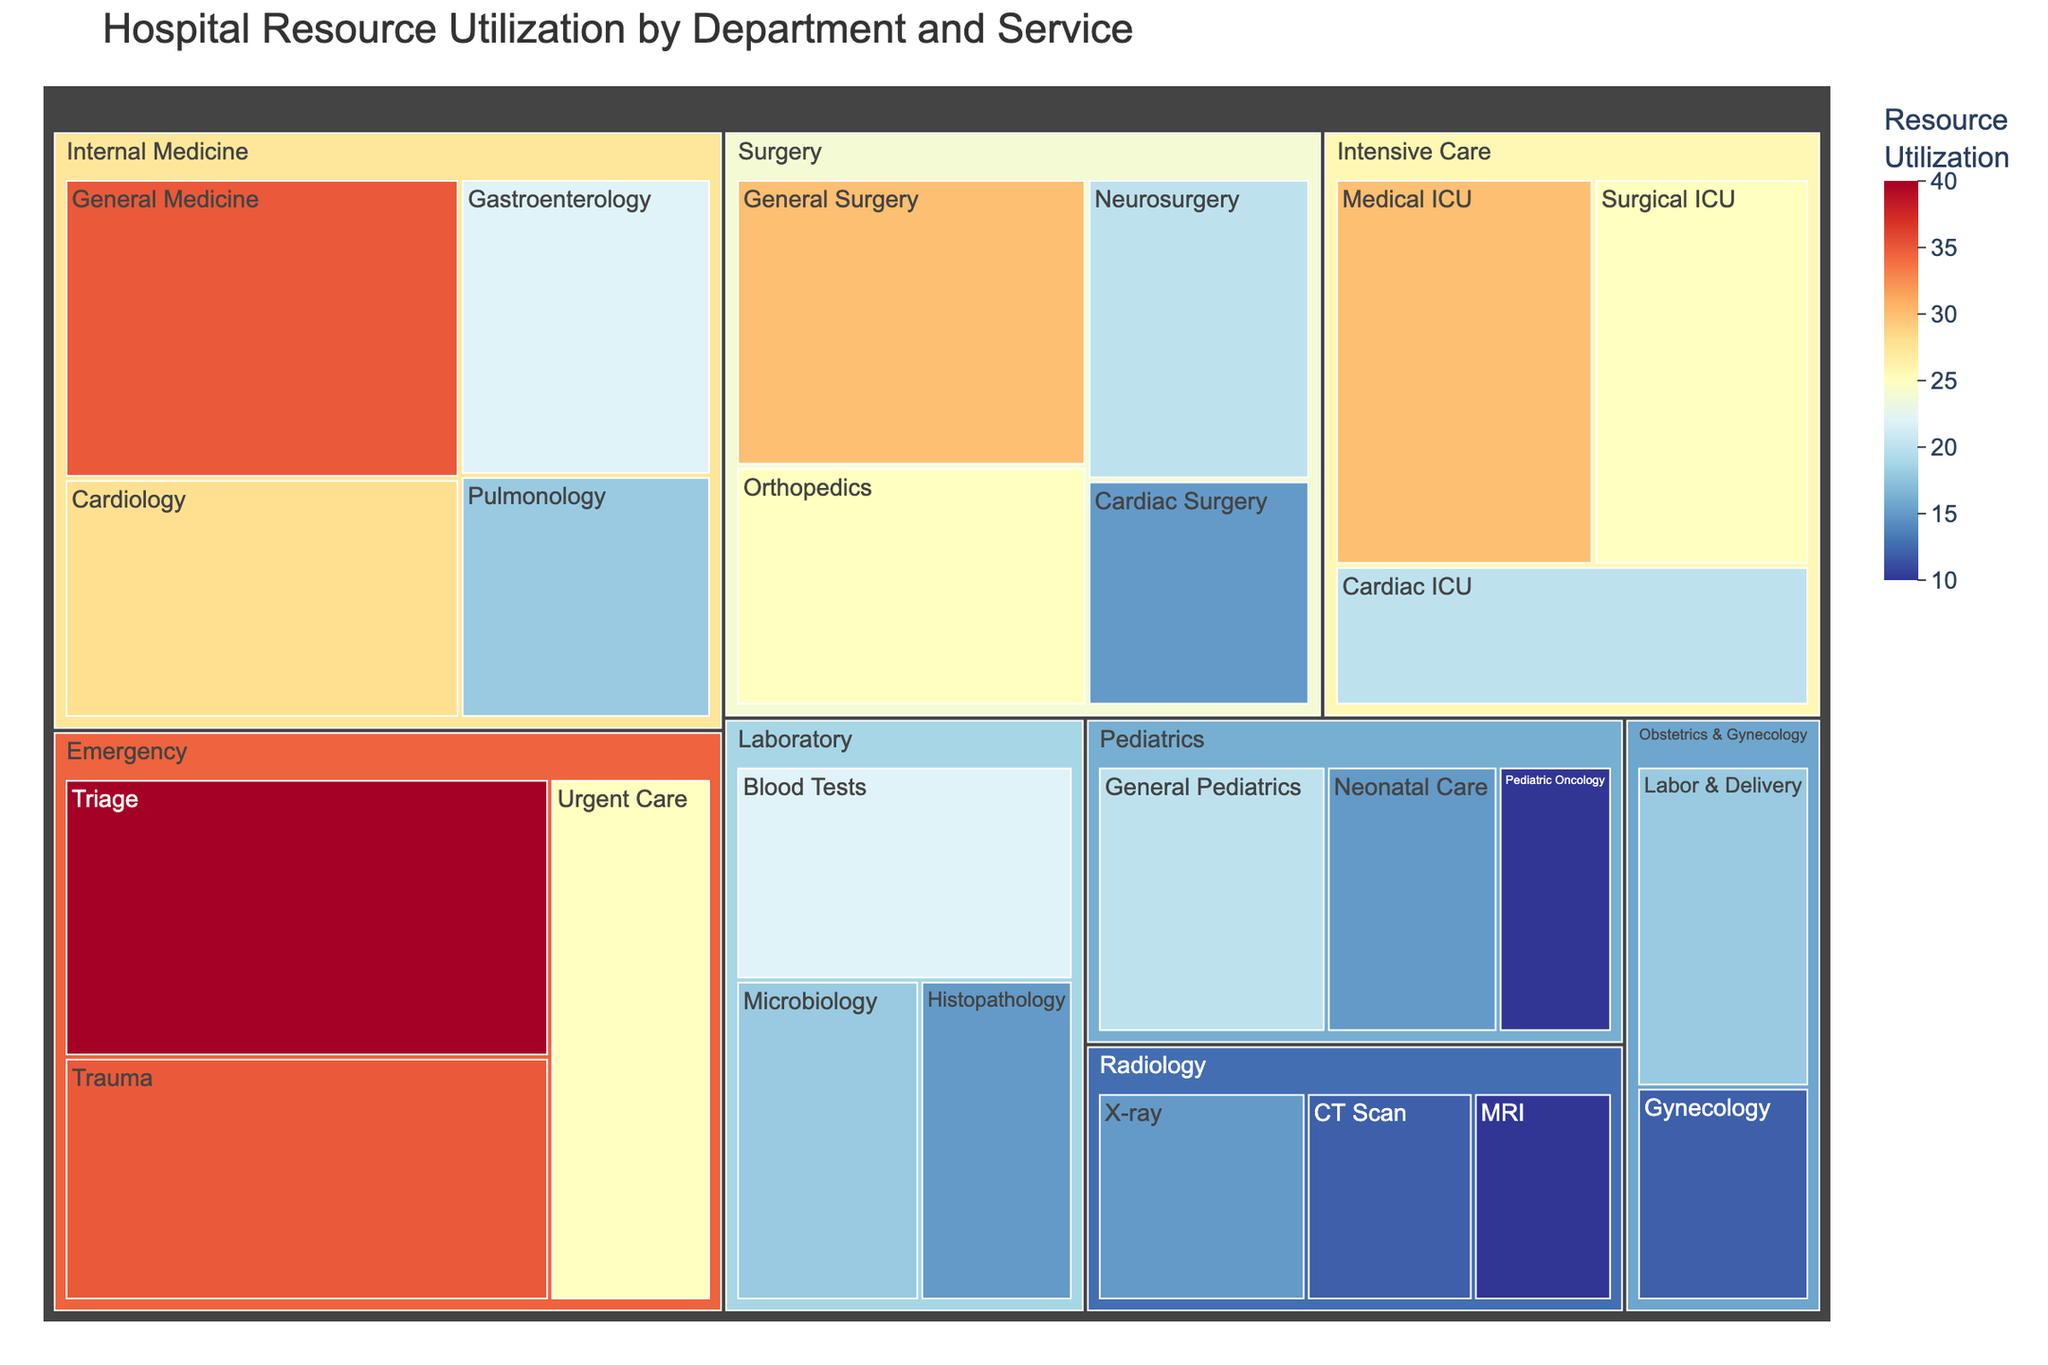What's the title of the treemap? The title is displayed at the top of the treemap.
Answer: Hospital Resource Utilization by Department and Service Which department has the largest resource utilization in General Medicine? The size of the box labeled "General Medicine" under the "Internal Medicine" department is the largest, representing 35 units.
Answer: Internal Medicine How much resource utilization does the Surgery department contribute in total? Sum the resource utilization values for all services within the Surgery department: 30 (General Surgery) + 25 (Orthopedics) + 20 (Neurosurgery) + 15 (Cardiac Surgery) = 90.
Answer: 90 Which service in the Emergency department has the smallest resource utilization? Among the services under the Emergency department, the smallest box is "Urgent Care" with a value of 25.
Answer: Urgent Care Is the resource utilization for Pediatrics larger or smaller than that for Obstetrics & Gynecology? Sum the resource utilization values for services in each department and compare: Pediatrics = 20 (General Pediatrics) + 15 (Neonatal Care) + 10 (Pediatric Oncology) = 45, Obstetrics & Gynecology = 18 (Labor & Delivery) + 12 (Gynecology) = 30.
Answer: Larger What is the average resource utilization for the Intensive Care services? Sum the values of all Intensive Care services and divide by the number of services: (30 + 25 + 20) / 3 = 75 / 3 = 25.
Answer: 25 What is the smallest resource utilization among all departments? Identify the smallest value among all labeled services within each department in the treemap: The smallest utilization is 10 for both "Pediatric Oncology" and "MRI".
Answer: 10 Does the Laboratory department have a service with over 20 units of resource utilization? Check the values of services within the Laboratory department: "Blood Tests" (22) exceeds 20 units.
Answer: Yes Which service in Radiology has the highest resource utilization? Compare the values of services within Radiology: "X-ray" with 15 units is the highest.
Answer: X-ray How do the total resource utilizations for Surgery and Intensive Care compare? Sum the values for each department and compare: Surgery = 30 + 25 + 20 + 15 = 90, Intensive Care = 30 + 25 + 20 = 75.
Answer: Surgery has a higher total than Intensive Care 